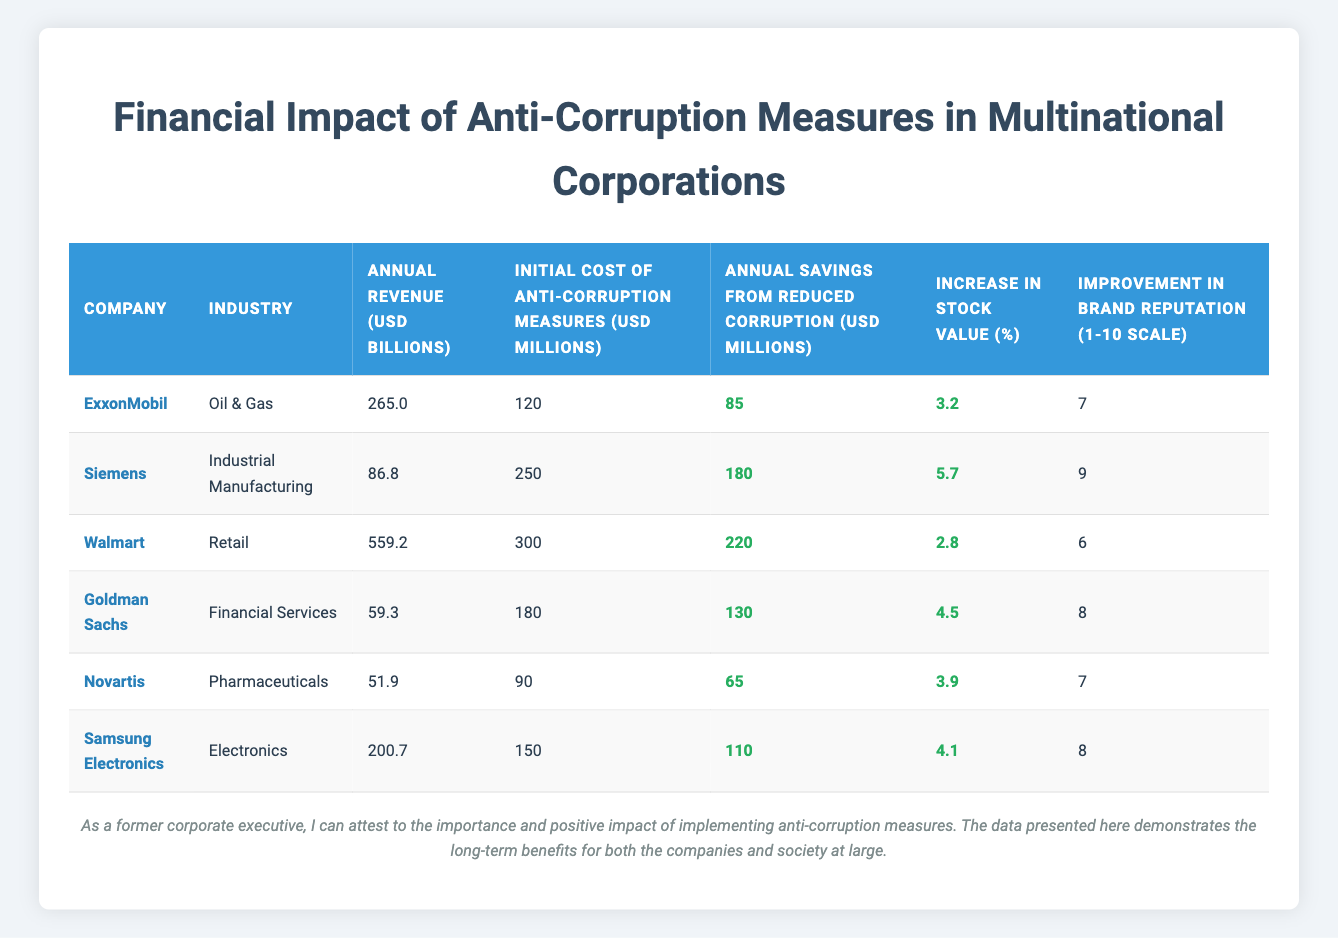What is the annual revenue of Walmart? The table lists the annual revenue for Walmart under the "Annual Revenue (USD billions)" column, which shows a value of 559.2 billion USD.
Answer: 559.2 billion USD Which company has the highest annual savings from reduced corruption? By comparing the "Annual Savings from Reduced Corruption (USD millions)" column, Walmart has the highest value of 220 million USD, which is greater than the other companies listed.
Answer: Walmart What is the total initial cost of anti-corruption measures for all companies combined? To find the total initial cost, sum the values from the "Initial Cost of Anti-Corruption Measures (USD millions)" column: 120 + 250 + 300 + 180 + 90 + 150 = 1,090 million USD.
Answer: 1,090 million USD Does Novartis have a better brand reputation rating than Samsung Electronics? Novartis has an improvement in brand reputation of 7 while Samsung Electronics has a rating of 8. Therefore, Novartis does not have a better rating than Samsung Electronics.
Answer: No What percentage increase in stock value does Siemens have compared to ExxonMobil? Siemens has an increase of 5.7%, while ExxonMobil has an increase of 3.2%. The difference is 5.7 - 3.2 = 2.5%, indicating Siemens has a higher percentage increase in stock value.
Answer: 2.5% Which industry has the most significant annual savings from reduced corruption? The "Annual Savings from Reduced Corruption (USD millions)" column shows that Walmart (Retail) has the highest savings with 220 million USD. All others are less than this value, confirming that the Retail industry is the most significant in this context.
Answer: Retail 